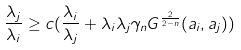Convert formula to latex. <formula><loc_0><loc_0><loc_500><loc_500>\frac { \lambda _ { j } } { \lambda _ { i } } \geq c ( \frac { \lambda _ { i } } { \lambda _ { j } } + \lambda _ { i } \lambda _ { j } \gamma _ { n } G ^ { \frac { 2 } { 2 - n } } ( a _ { i } , a _ { j } ) )</formula> 